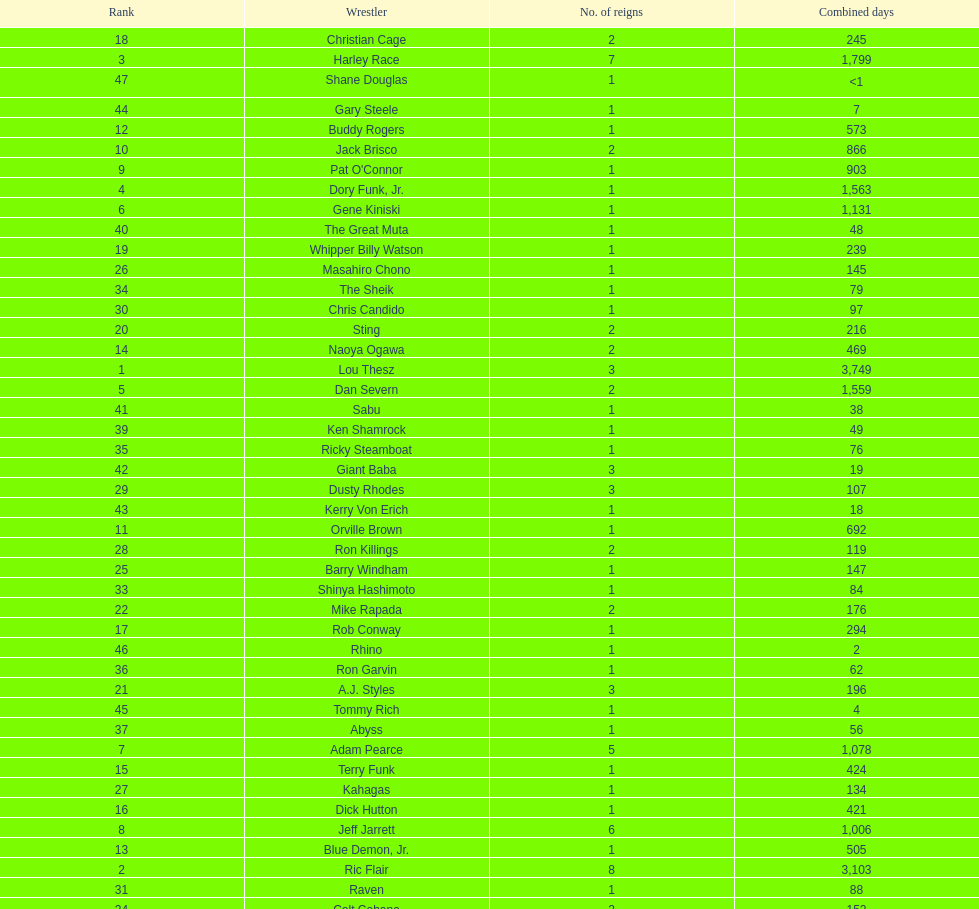Which professional wrestler has had the most number of reigns as nwa world heavyweight champion? Ric Flair. 